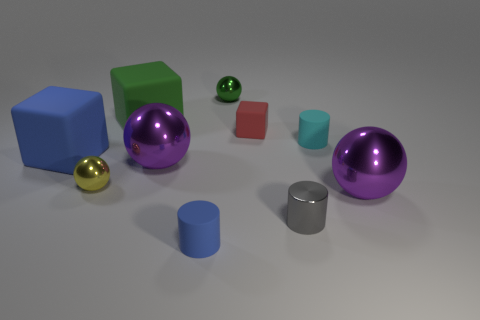There is a object that is in front of the tiny yellow metal sphere and behind the gray metal thing; what is its material?
Offer a terse response. Metal. Is the tiny gray cylinder made of the same material as the big cube that is on the right side of the tiny yellow shiny sphere?
Offer a terse response. No. Is the number of rubber cylinders that are in front of the tiny green ball greater than the number of small spheres that are to the left of the green matte thing?
Provide a short and direct response. Yes. The yellow metallic object has what shape?
Provide a succinct answer. Sphere. Are the small blue thing in front of the big blue rubber block and the purple object that is to the left of the small block made of the same material?
Keep it short and to the point. No. There is a big purple metallic thing left of the tiny red rubber block; what is its shape?
Provide a succinct answer. Sphere. What size is the cyan matte object that is the same shape as the gray thing?
Offer a very short reply. Small. There is a cube right of the tiny blue rubber cylinder; is there a cube to the right of it?
Offer a very short reply. No. The other large matte object that is the same shape as the big green object is what color?
Your response must be concise. Blue. The big thing that is in front of the large metallic thing to the left of the large purple thing that is in front of the small yellow ball is what color?
Offer a very short reply. Purple. 